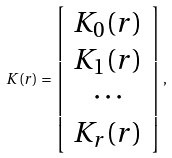<formula> <loc_0><loc_0><loc_500><loc_500>K ( r ) = \left [ \begin{array} { c } K _ { 0 } ( r ) \\ K _ { 1 } ( r ) \\ \cdots \\ K _ { r } ( r ) \end{array} \right ] ,</formula> 